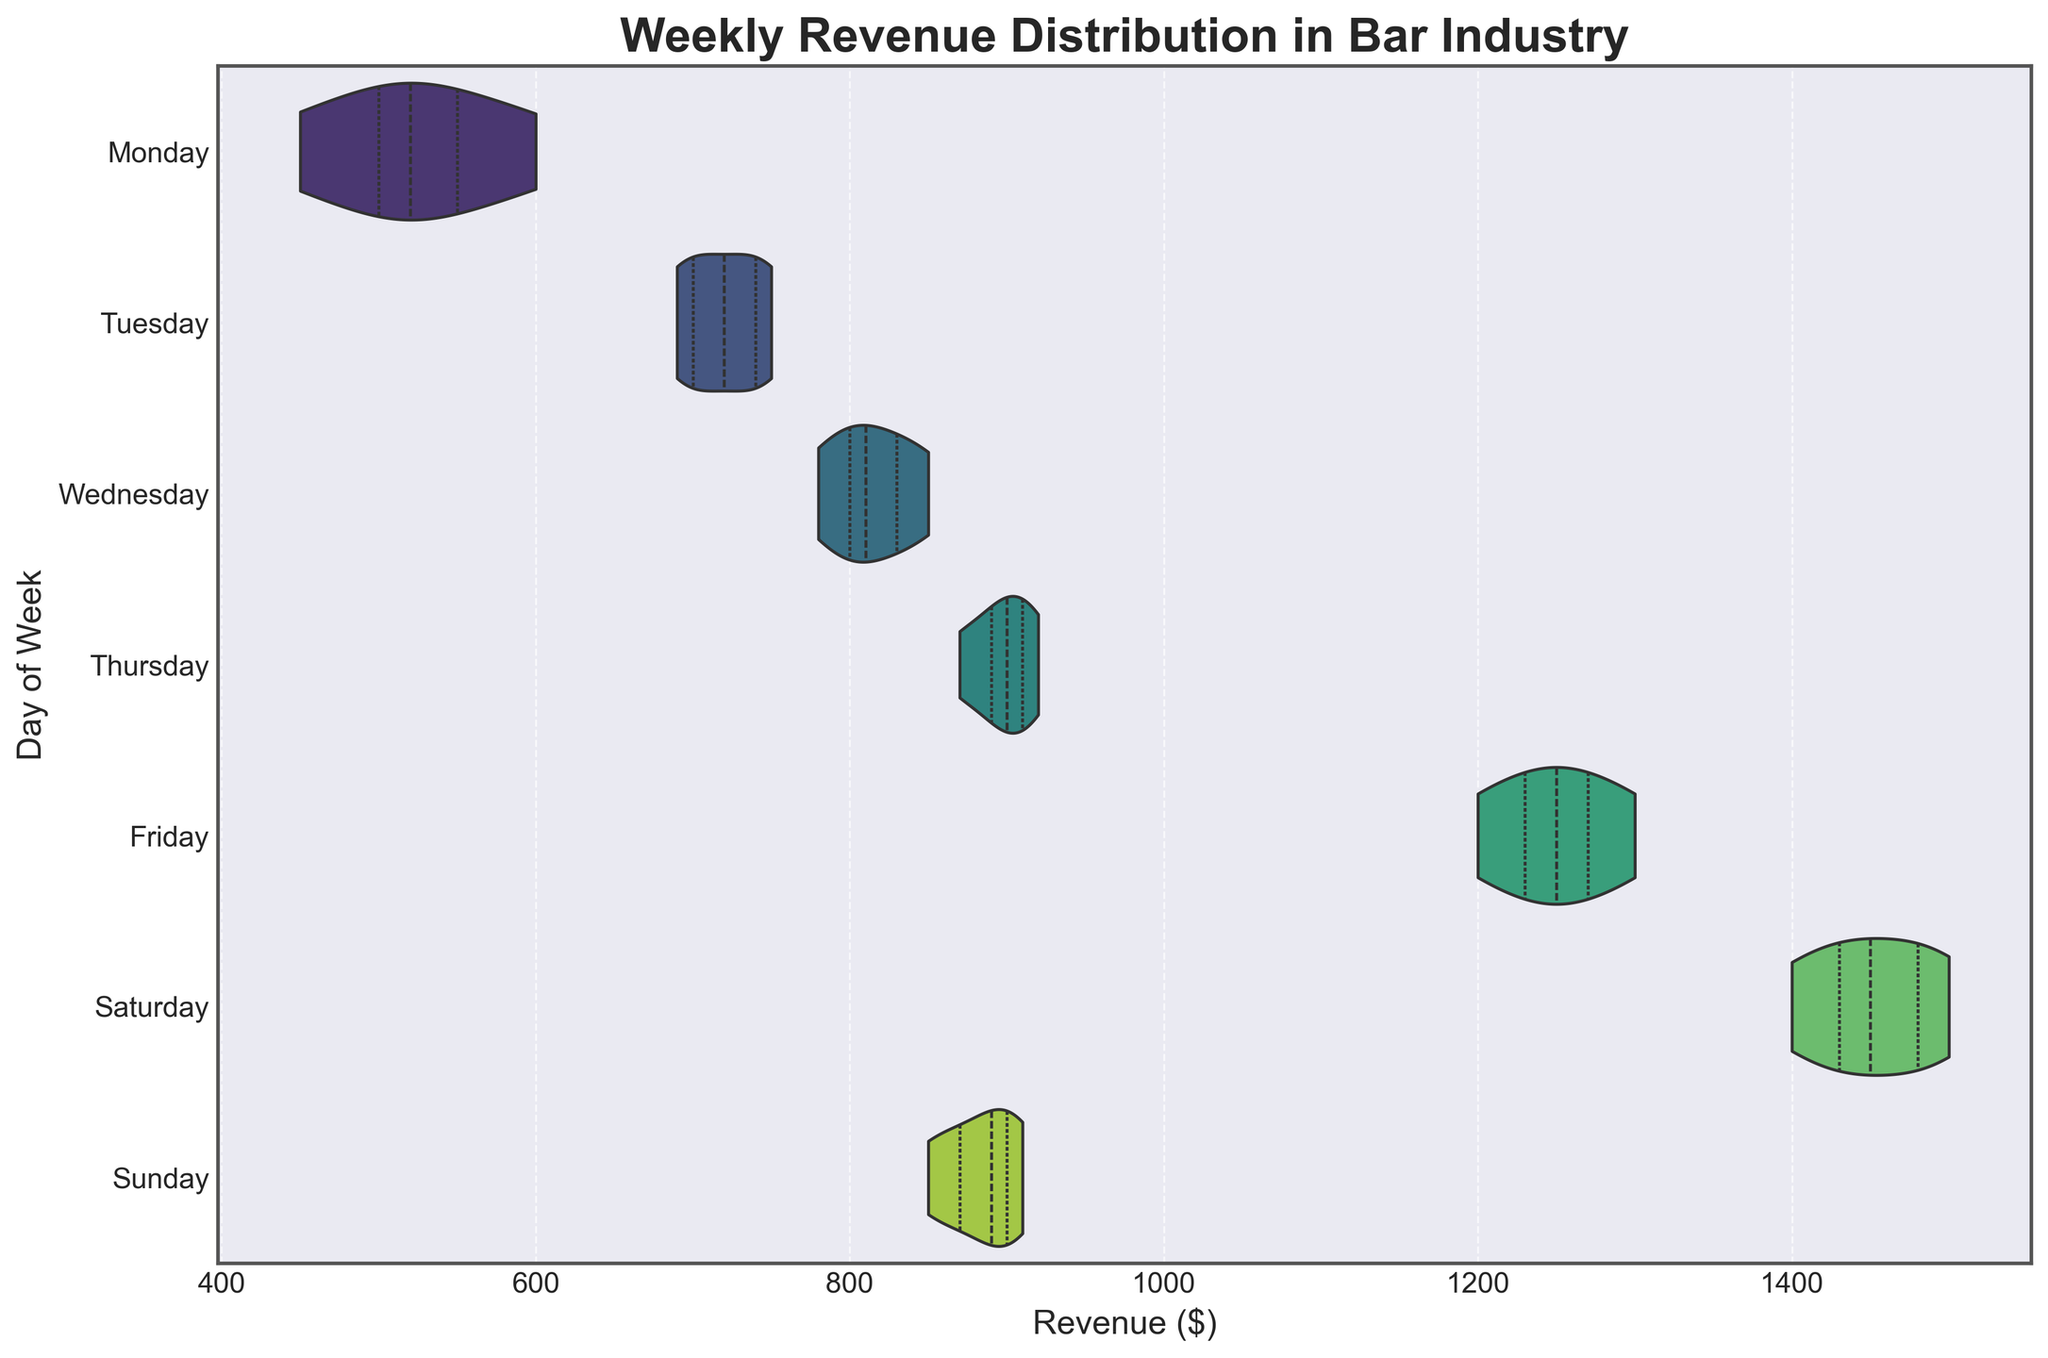What is the range of the revenue on Friday? The range of revenue refers to the difference between the maximum and minimum values. For Friday, the minimum revenue is $1200 and the maximum revenue is $1300. Therefore, the range is $1300 - $1200.
Answer: $100 Which day has the highest median revenue? The median revenue divides the data into two equal halves. Visually, the thickest part of the violin plot represents the median. Saturday's distribution appears to have the highest median as it is located furthest to the right compared to other days.
Answer: Saturday What day shows the widest spread of revenue distribution? The spread of the distribution can be estimated by how wide the violin plot is horizontally. Saturday has the widest spread since the distribution extends significantly compared to other days.
Answer: Saturday Between Monday and Wednesday, which day has a higher interquartile range (IQR)? The interquartile range is the width of the box inside the violin plot (representing the middle 50% of the data). Visually, Wednesday's IQR appears wider than Monday's, indicating a higher interquartile range.
Answer: Wednesday Which day has the most consistent revenue distribution? Consistency can be assessed by how narrow and concentrated the violin plot appears. Monday's plot is more concentrated and narrower, indicating more consistent revenue.
Answer: Monday On which day does the revenue have the highest variability? Variability can be seen by the overall width and spread of the violin plot. Saturday's distribution is the widest, indicating the highest variability in revenue.
Answer: Saturday How do the median revenues of Tuesday and Sunday compare? By comparing the positions of the medians (thick part of the violins) for Tuesday and Sunday, Tuesday's median appears higher than that of Sunday.
Answer: Tuesday is higher What is the approximate median revenue for Thursday? The median is at the widest part of the violin plot (dark line inside the plot). For Thursday, it appears around the $890 mark.
Answer: $890 Which day shows the smallest interquartile range (IQR) and what does it imply about the revenue? The smallest IQR can be assessed by the width of the box inside the violin plot. Monday has the smallest IQR, indicating less variability and more consistency in the middle 50% of revenue data.
Answer: Monday, implying more consistent revenue 